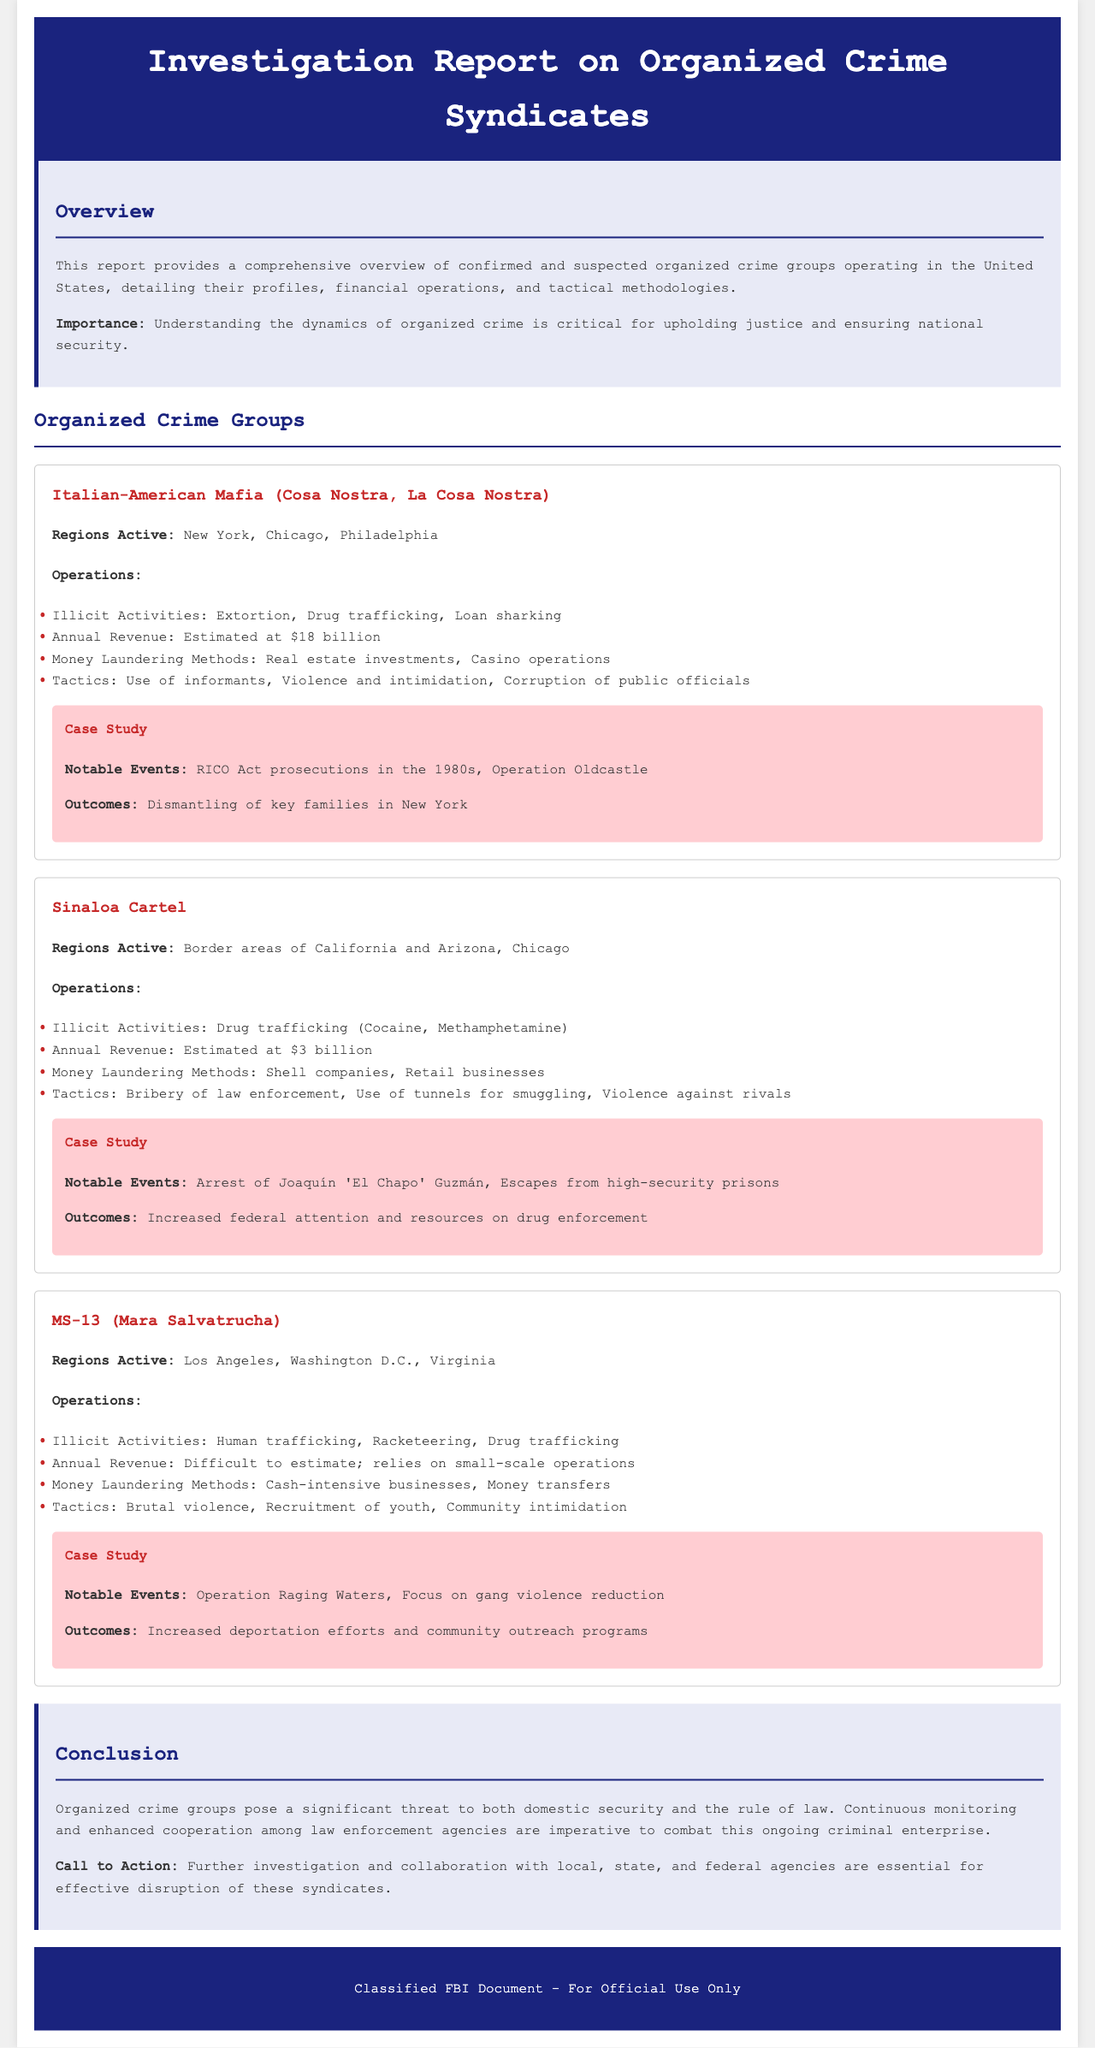What is the estimated annual revenue of the Italian-American Mafia? The document states the estimated annual revenue of the Italian-American Mafia is $18 billion.
Answer: $18 billion What illicit activities are associated with the Sinaloa Cartel? The report lists drug trafficking (Cocaine, Methamphetamine) as the illicit activities associated with the Sinaloa Cartel.
Answer: Drug trafficking (Cocaine, Methamphetamine) Which regions are active for MS-13? The document identifies Los Angeles, Washington D.C., and Virginia as the regions active for MS-13.
Answer: Los Angeles, Washington D.C., Virginia What are the money laundering methods used by the Sinaloa Cartel? The money laundering methods listed for the Sinaloa Cartel include shell companies and retail businesses.
Answer: Shell companies, Retail businesses What was one notable event related to the Italian-American Mafia? The report mentions RICO Act prosecutions in the 1980s as a notable event related to the Italian-American Mafia.
Answer: RICO Act prosecutions in the 1980s What tactics does MS-13 employ? The tactics employed by MS-13 include brutal violence, recruitment of youth, and community intimidation.
Answer: Brutal violence, Recruitment of youth, Community intimidation What is the conclusion about organized crime groups? The conclusion states organized crime groups pose a significant threat to domestic security and the rule of law.
Answer: Significant threat to domestic security and the rule of law What was the outcome of Operation Raging Waters? The document states that the outcome was increased deportation efforts and community outreach programs.
Answer: Increased deportation efforts and community outreach programs In which regions does the Sinaloa Cartel primarily operate? The report identifies border areas of California and Arizona, as well as Chicago, as the primary regions of operation for the Sinaloa Cartel.
Answer: Border areas of California and Arizona, Chicago 